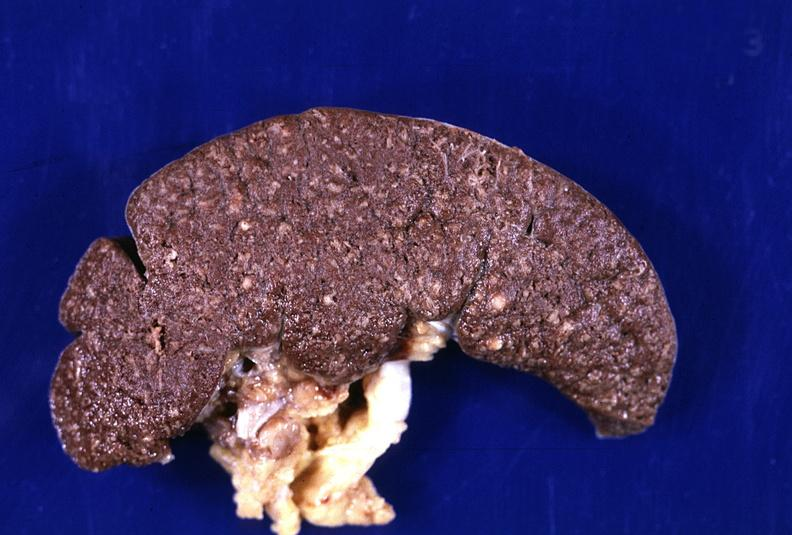does this image show spleen, tuberculosis, granulomas?
Answer the question using a single word or phrase. Yes 